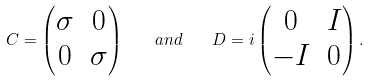<formula> <loc_0><loc_0><loc_500><loc_500>C = \begin{pmatrix} \sigma & 0 \\ 0 & \sigma \end{pmatrix} \quad a n d \quad D = i \begin{pmatrix} 0 & I \\ - I & 0 \end{pmatrix} .</formula> 